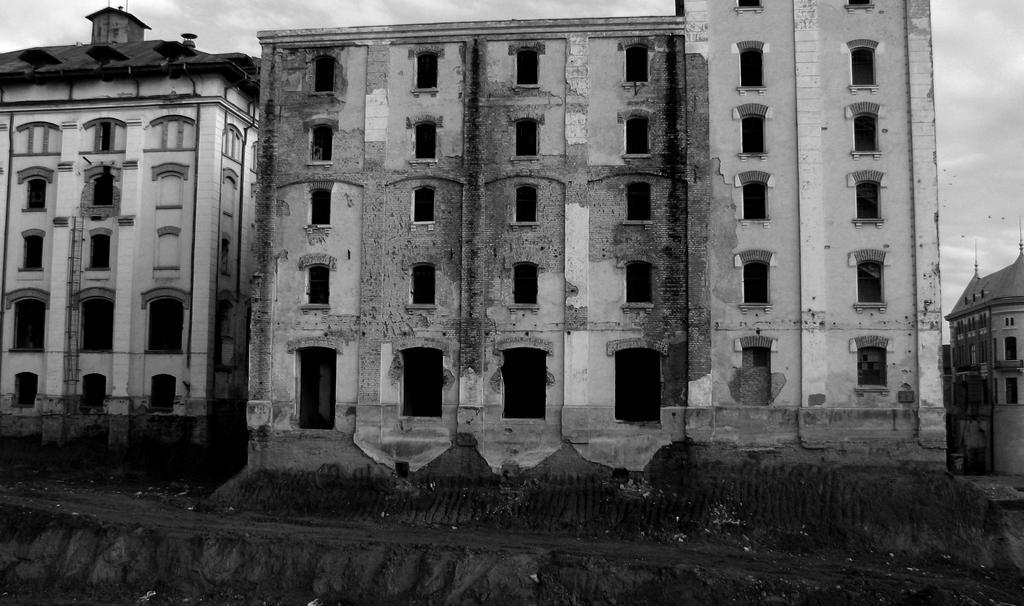Can you describe this image briefly? This is a black and white image. There are buildings. 